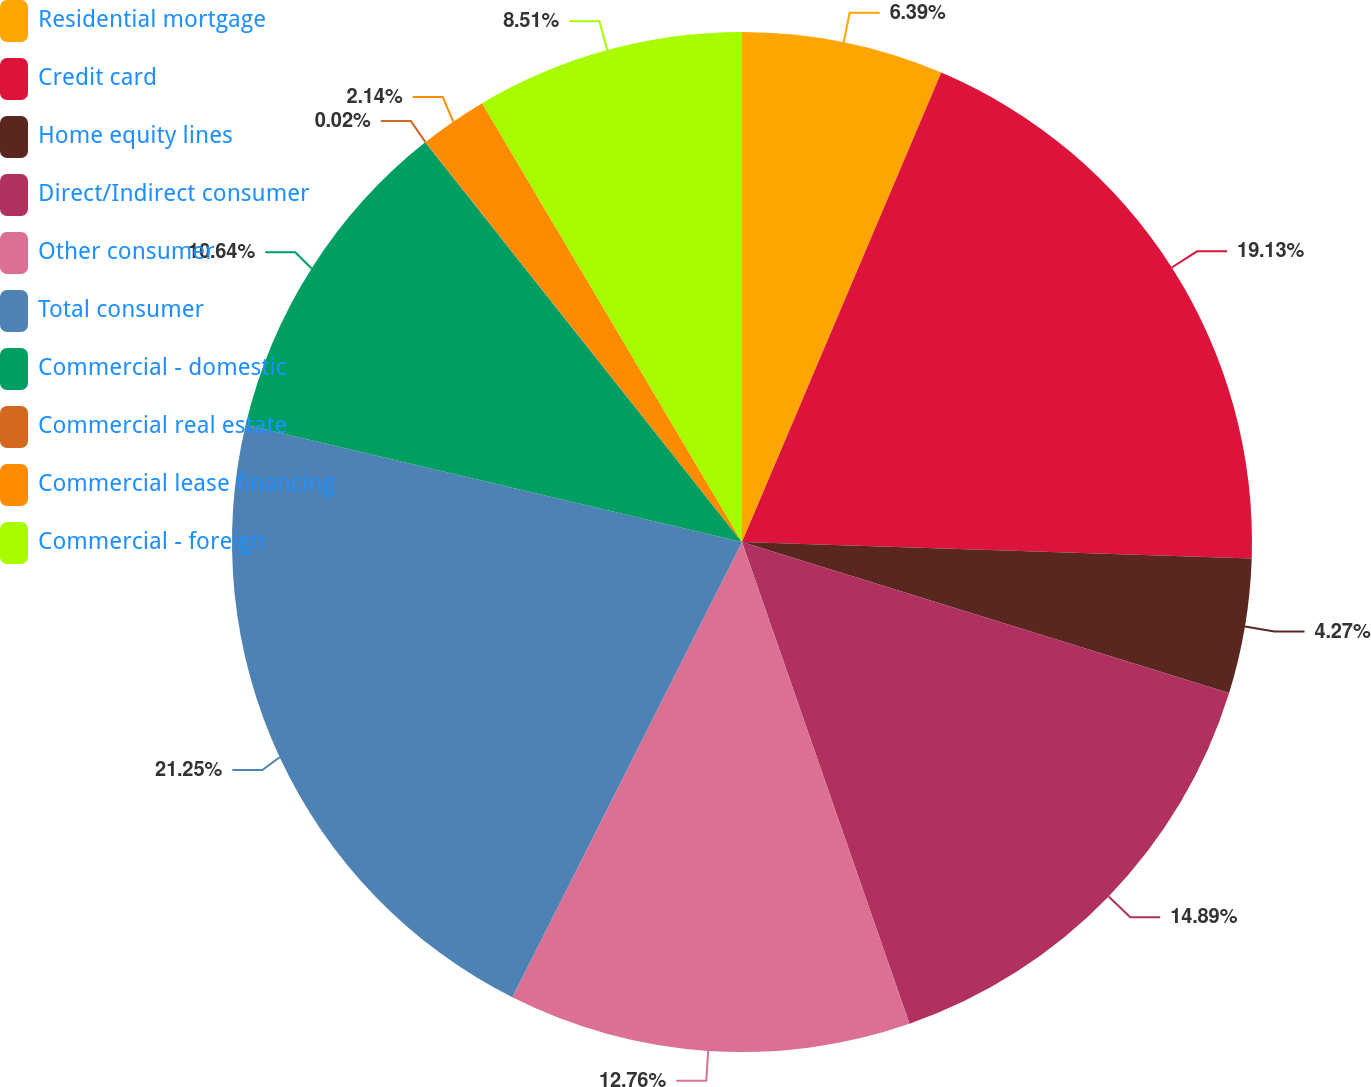Convert chart to OTSL. <chart><loc_0><loc_0><loc_500><loc_500><pie_chart><fcel>Residential mortgage<fcel>Credit card<fcel>Home equity lines<fcel>Direct/Indirect consumer<fcel>Other consumer<fcel>Total consumer<fcel>Commercial - domestic<fcel>Commercial real estate<fcel>Commercial lease financing<fcel>Commercial - foreign<nl><fcel>6.39%<fcel>19.13%<fcel>4.27%<fcel>14.89%<fcel>12.76%<fcel>21.26%<fcel>10.64%<fcel>0.02%<fcel>2.14%<fcel>8.51%<nl></chart> 